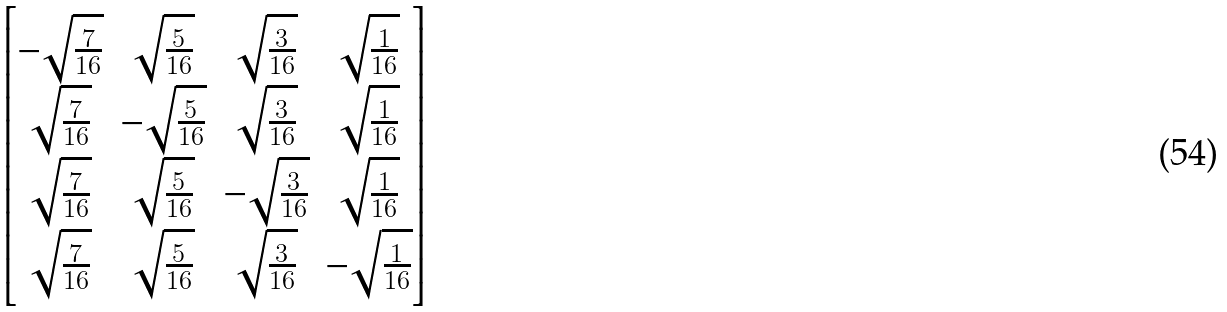Convert formula to latex. <formula><loc_0><loc_0><loc_500><loc_500>\begin{bmatrix} - \sqrt { \frac { 7 } { 1 6 } } & \sqrt { \frac { 5 } { 1 6 } } & \sqrt { \frac { 3 } { 1 6 } } & \sqrt { \frac { 1 } { 1 6 } } \\ \sqrt { \frac { 7 } { 1 6 } } & - \sqrt { \frac { 5 } { 1 6 } } & \sqrt { \frac { 3 } { 1 6 } } & \sqrt { \frac { 1 } { 1 6 } } \\ \sqrt { \frac { 7 } { 1 6 } } & \sqrt { \frac { 5 } { 1 6 } } & - \sqrt { \frac { 3 } { 1 6 } } & \sqrt { \frac { 1 } { 1 6 } } \\ \sqrt { \frac { 7 } { 1 6 } } & \sqrt { \frac { 5 } { 1 6 } } & \sqrt { \frac { 3 } { 1 6 } } & - \sqrt { \frac { 1 } { 1 6 } } \\ \end{bmatrix}</formula> 